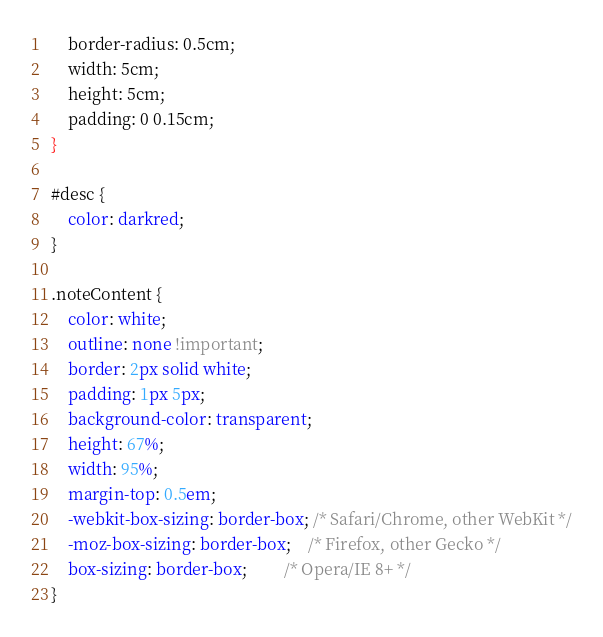<code> <loc_0><loc_0><loc_500><loc_500><_CSS_>    border-radius: 0.5cm;
    width: 5cm;
    height: 5cm;
    padding: 0 0.15cm;
}

#desc {
    color: darkred;
}

.noteContent {
    color: white;
    outline: none !important;
    border: 2px solid white;
    padding: 1px 5px;
    background-color: transparent;
    height: 67%;
    width: 95%;
    margin-top: 0.5em;
    -webkit-box-sizing: border-box; /* Safari/Chrome, other WebKit */
    -moz-box-sizing: border-box;    /* Firefox, other Gecko */
    box-sizing: border-box;         /* Opera/IE 8+ */
}</code> 